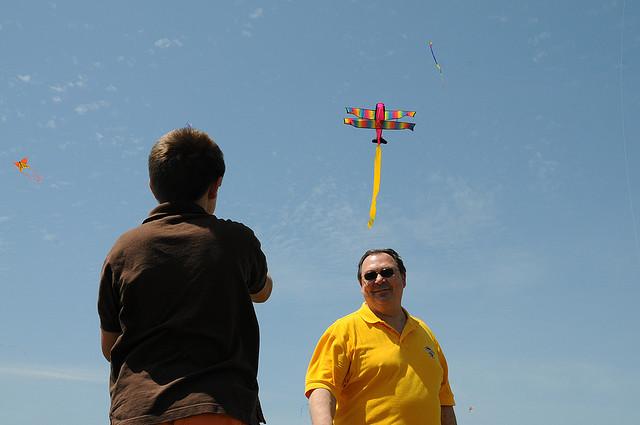Are these two friends?
Quick response, please. Yes. Is the man wearing glasses?
Give a very brief answer. Yes. Is it raining?
Write a very short answer. No. What is the boy doing?
Keep it brief. Flying kite. 